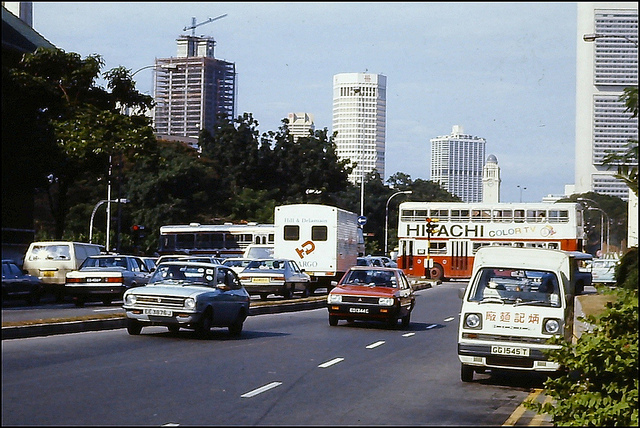Can you describe the setting and the type of vehicles present in this image? The image depicts a bustling urban street scene with a mix of personal cars, trucks, and buses. There's a notable presence of commercial advertising on a bus, indicative of a commercialized urban environment. Does the image give any indication of the location or country? While the specific location is not identified, the presence of English text on vehicles and signs could suggest an English-speaking country or a region with strong ties to English-speaking culture. 